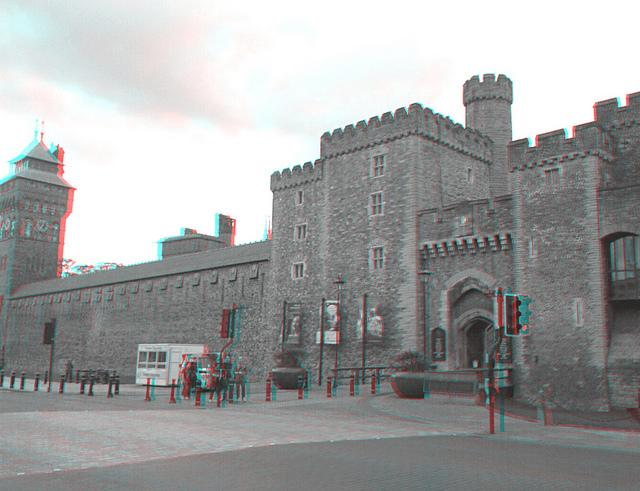What sort of building stand in could this building substitute for in a movie? Please explain your reasoning. castle. By the design and what materials was used to make this structure it's easy to get the correct answer. 